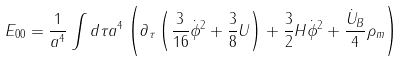<formula> <loc_0><loc_0><loc_500><loc_500>E _ { 0 0 } = \frac { 1 } { a ^ { 4 } } \int d \tau a ^ { 4 } \left ( \partial _ { \tau } \left ( \frac { 3 } { 1 6 } \dot { \phi } ^ { 2 } + \frac { 3 } { 8 } U \right ) + \frac { 3 } { 2 } H \dot { \phi } ^ { 2 } + \frac { \dot { U } _ { B } } { 4 } \rho _ { m } \right )</formula> 